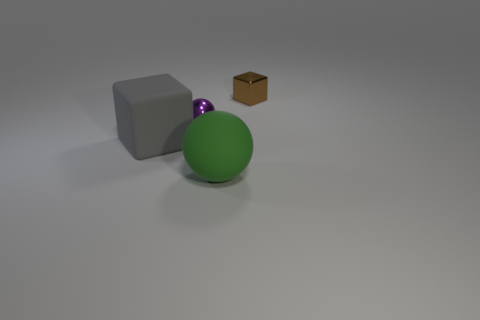How does the lighting in the scene affect the appearance of the objects? The lighting in the scene appears to be diffused overhead lighting, softening shadows and highlights, which allows the intrinsic colors and materials of the objects to be more visible. It gives a clearer differentiation between the matte surfaces like the grey block and the metallic sheen on the small purple ball. 